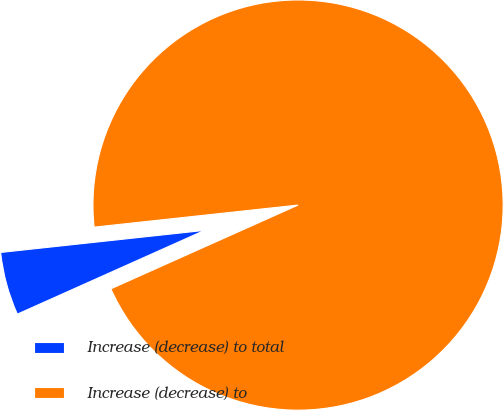Convert chart. <chart><loc_0><loc_0><loc_500><loc_500><pie_chart><fcel>Increase (decrease) to total<fcel>Increase (decrease) to<nl><fcel>4.98%<fcel>95.02%<nl></chart> 